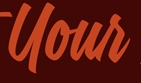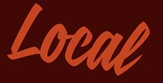What words are shown in these images in order, separated by a semicolon? Your; Local 